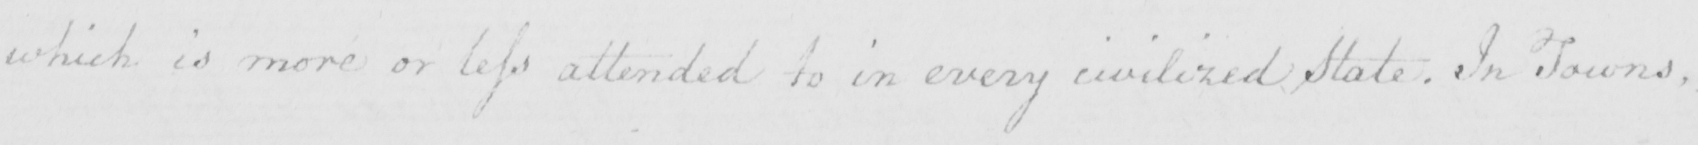Can you tell me what this handwritten text says? which is more or less attended to in every civilized State . In Towns , 